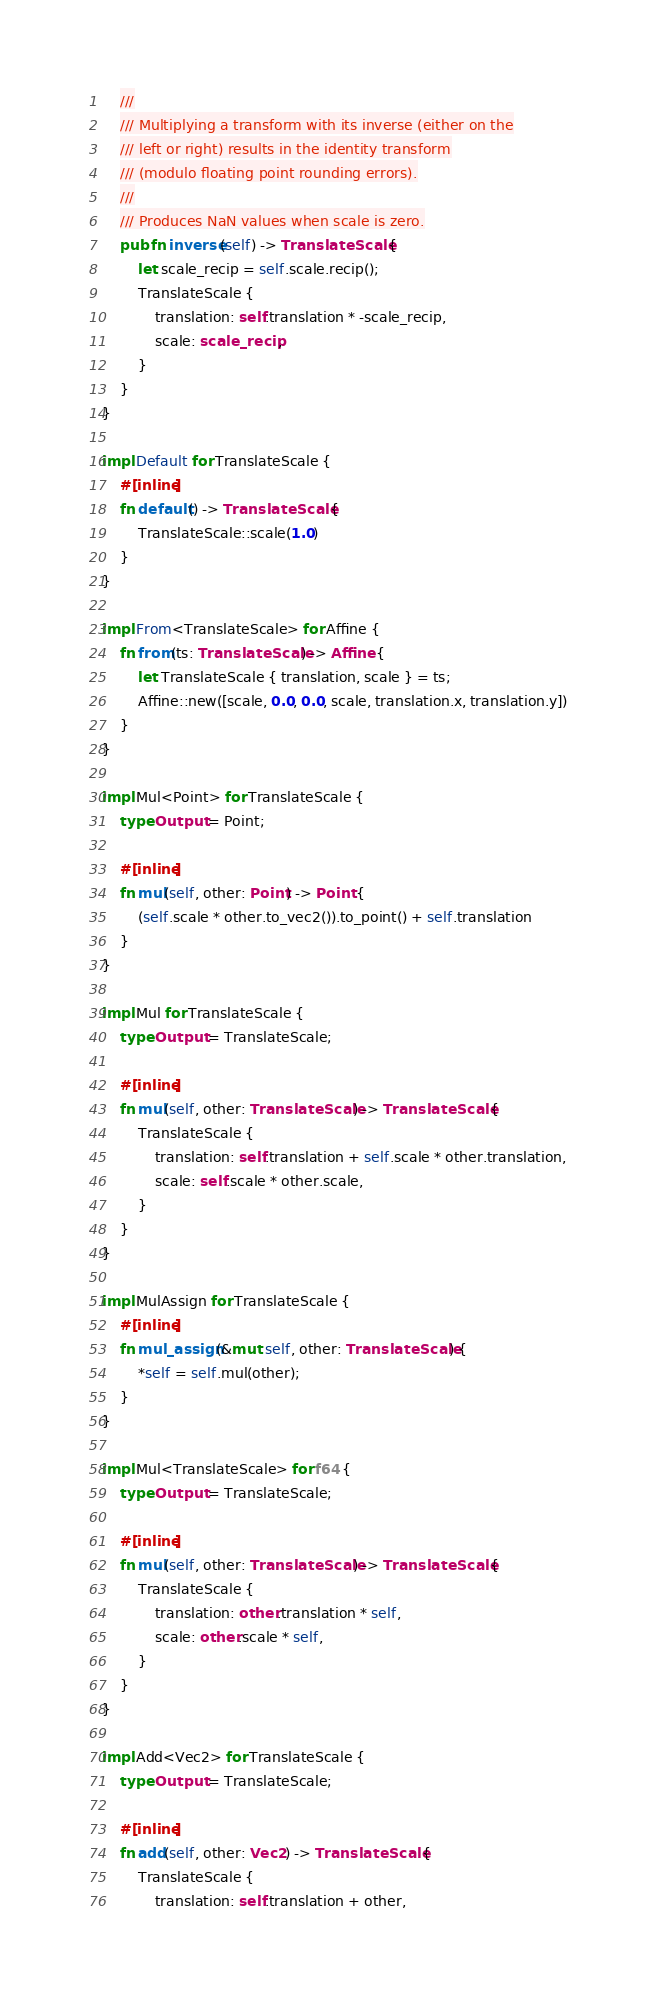Convert code to text. <code><loc_0><loc_0><loc_500><loc_500><_Rust_>    ///
    /// Multiplying a transform with its inverse (either on the
    /// left or right) results in the identity transform
    /// (modulo floating point rounding errors).
    ///
    /// Produces NaN values when scale is zero.
    pub fn inverse(self) -> TranslateScale {
        let scale_recip = self.scale.recip();
        TranslateScale {
            translation: self.translation * -scale_recip,
            scale: scale_recip,
        }
    }
}

impl Default for TranslateScale {
    #[inline]
    fn default() -> TranslateScale {
        TranslateScale::scale(1.0)
    }
}

impl From<TranslateScale> for Affine {
    fn from(ts: TranslateScale) -> Affine {
        let TranslateScale { translation, scale } = ts;
        Affine::new([scale, 0.0, 0.0, scale, translation.x, translation.y])
    }
}

impl Mul<Point> for TranslateScale {
    type Output = Point;

    #[inline]
    fn mul(self, other: Point) -> Point {
        (self.scale * other.to_vec2()).to_point() + self.translation
    }
}

impl Mul for TranslateScale {
    type Output = TranslateScale;

    #[inline]
    fn mul(self, other: TranslateScale) -> TranslateScale {
        TranslateScale {
            translation: self.translation + self.scale * other.translation,
            scale: self.scale * other.scale,
        }
    }
}

impl MulAssign for TranslateScale {
    #[inline]
    fn mul_assign(&mut self, other: TranslateScale) {
        *self = self.mul(other);
    }
}

impl Mul<TranslateScale> for f64 {
    type Output = TranslateScale;

    #[inline]
    fn mul(self, other: TranslateScale) -> TranslateScale {
        TranslateScale {
            translation: other.translation * self,
            scale: other.scale * self,
        }
    }
}

impl Add<Vec2> for TranslateScale {
    type Output = TranslateScale;

    #[inline]
    fn add(self, other: Vec2) -> TranslateScale {
        TranslateScale {
            translation: self.translation + other,</code> 